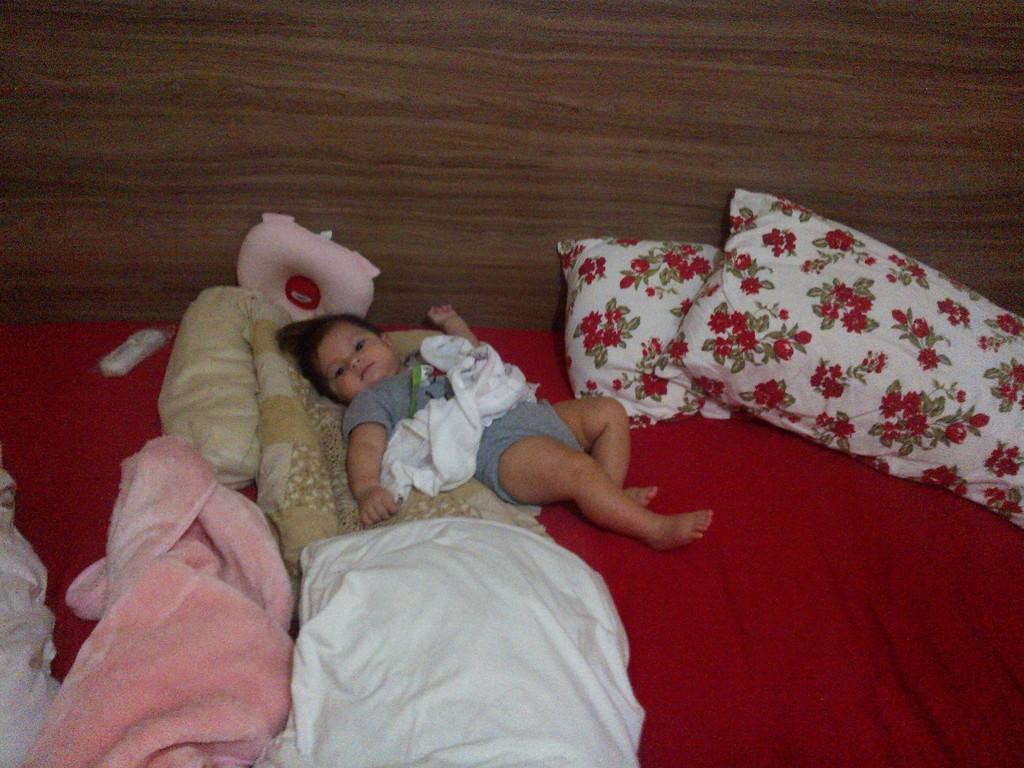What is the main subject of the image? There is a baby on a bed in the image. What is surrounding the baby on the bed? There are blankets and pillows around the baby. What can be seen in the background of the image? There is a wooden wall in the background. What type of flower is being discussed by the baby in the image? There is no flower or discussion present in the image; it features a baby on a bed surrounded by blankets and pillows. 